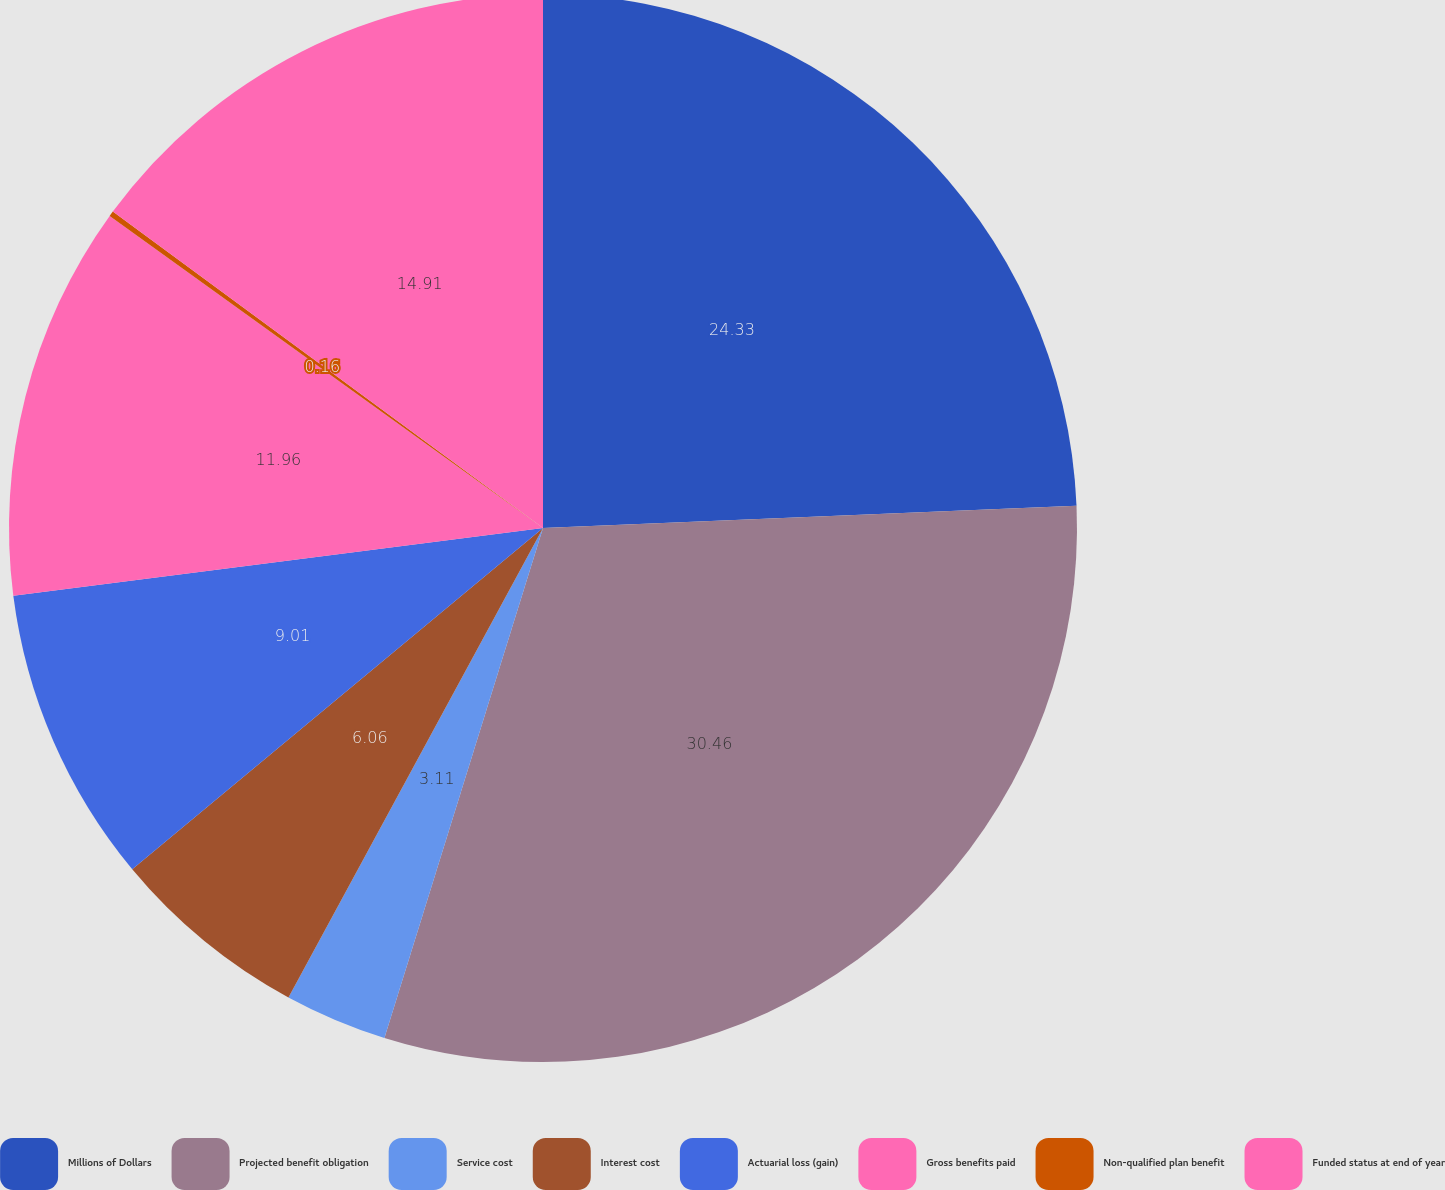Convert chart to OTSL. <chart><loc_0><loc_0><loc_500><loc_500><pie_chart><fcel>Millions of Dollars<fcel>Projected benefit obligation<fcel>Service cost<fcel>Interest cost<fcel>Actuarial loss (gain)<fcel>Gross benefits paid<fcel>Non-qualified plan benefit<fcel>Funded status at end of year<nl><fcel>24.34%<fcel>30.47%<fcel>3.11%<fcel>6.06%<fcel>9.01%<fcel>11.96%<fcel>0.16%<fcel>14.91%<nl></chart> 